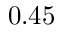<formula> <loc_0><loc_0><loc_500><loc_500>0 . 4 5</formula> 